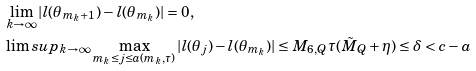<formula> <loc_0><loc_0><loc_500><loc_500>& \lim _ { k \rightarrow \infty } | l ( \theta _ { m _ { k } + 1 } ) - l ( \theta _ { m _ { k } } ) | = 0 , \\ & \lim s u p _ { k \rightarrow \infty } \max _ { m _ { k } \leq j \leq a ( m _ { k } , \tau ) } | l ( \theta _ { j } ) - l ( \theta _ { m _ { k } } ) | \leq M _ { 6 , Q } \tau ( \tilde { M } _ { Q } + \eta ) \leq \delta < c - a</formula> 